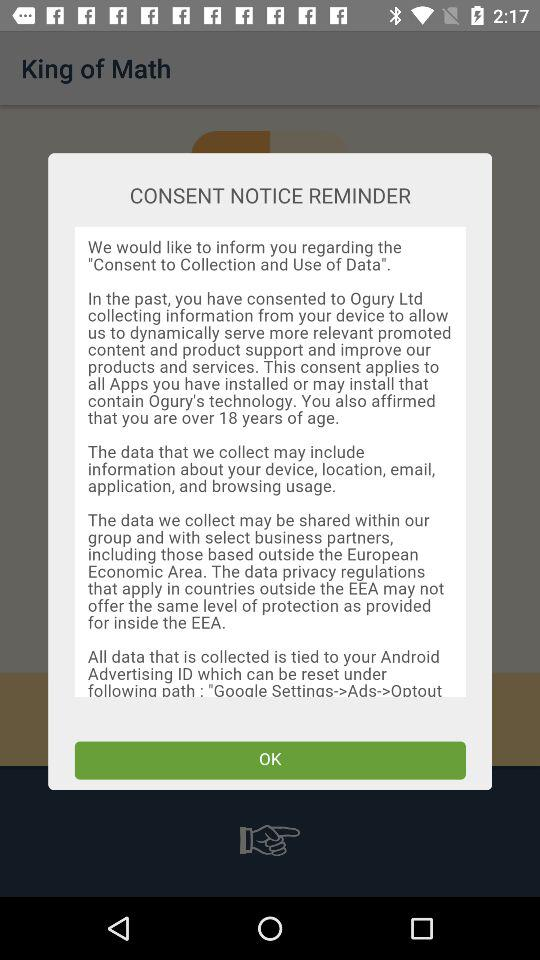How many different types of data does Ogury collect?
Answer the question using a single word or phrase. 5 